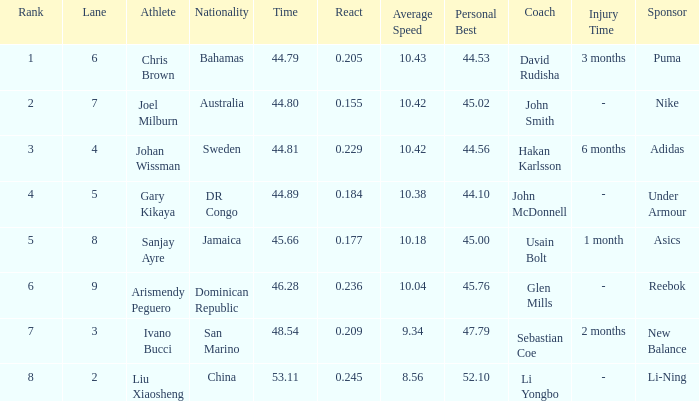How many total Rank listings have Liu Xiaosheng listed as the athlete with a react entry that is smaller than 0.245? 0.0. 